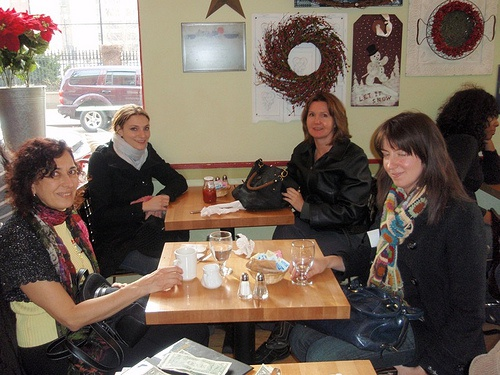Describe the objects in this image and their specific colors. I can see people in white, black, maroon, and gray tones, people in white, black, gray, tan, and maroon tones, dining table in white, tan, gray, lightgray, and brown tones, people in white, black, brown, darkgray, and gray tones, and people in white, black, brown, and maroon tones in this image. 